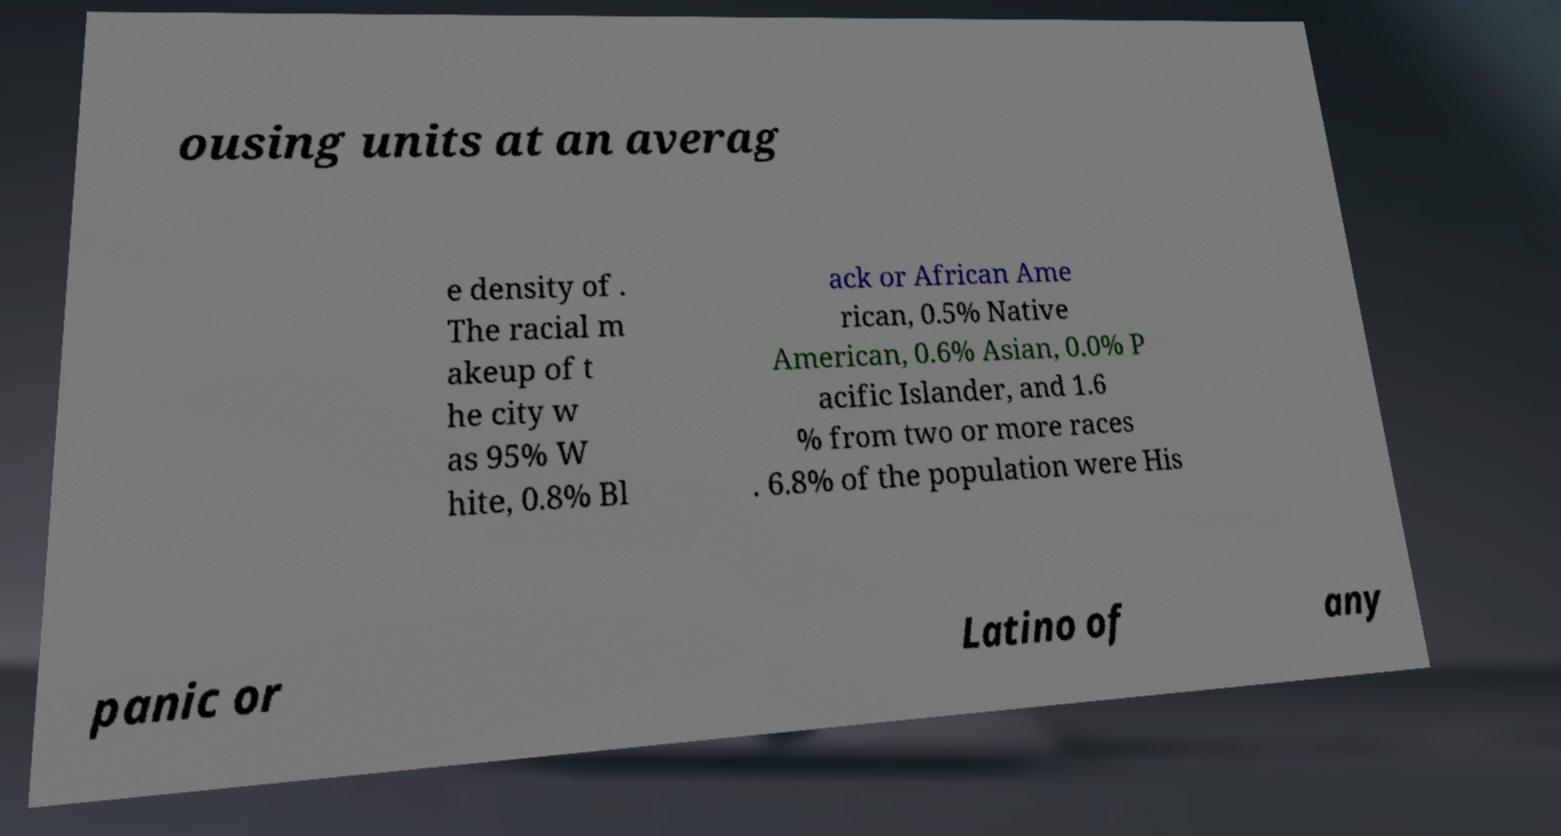Could you assist in decoding the text presented in this image and type it out clearly? ousing units at an averag e density of . The racial m akeup of t he city w as 95% W hite, 0.8% Bl ack or African Ame rican, 0.5% Native American, 0.6% Asian, 0.0% P acific Islander, and 1.6 % from two or more races . 6.8% of the population were His panic or Latino of any 